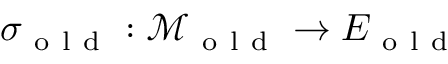Convert formula to latex. <formula><loc_0><loc_0><loc_500><loc_500>\sigma _ { o l d } \colon \mathcal { M } _ { o l d } \to E _ { o l d }</formula> 